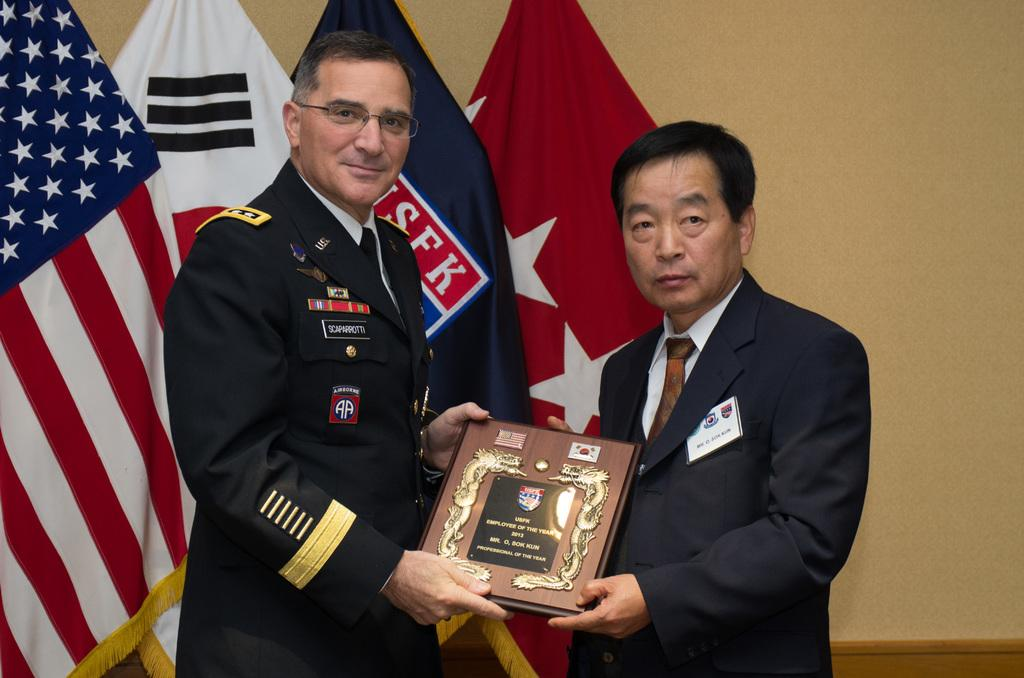How many people are in the image? There are two persons in the image. What are the persons wearing? The persons are wearing clothes. What are the persons holding in the image? The persons are holding a memorandum. What can be seen in front of the wall in the image? There are flags in front of a wall in the image. What type of leather can be seen on the bike in the image? There is no bike present in the image, so there is no leather to be seen. 